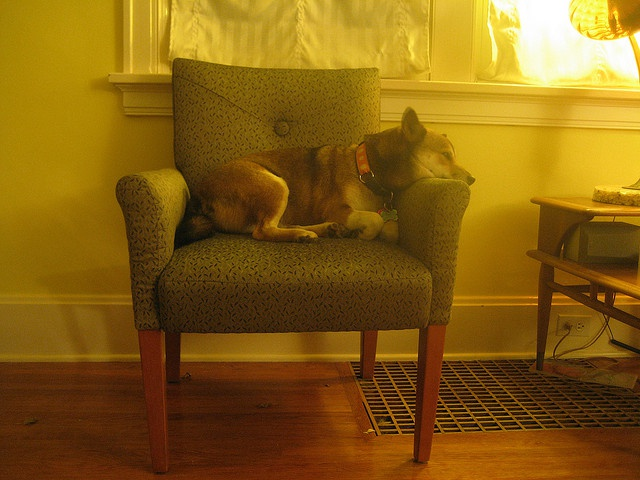Describe the objects in this image and their specific colors. I can see chair in olive, maroon, and black tones and dog in olive, maroon, and black tones in this image. 